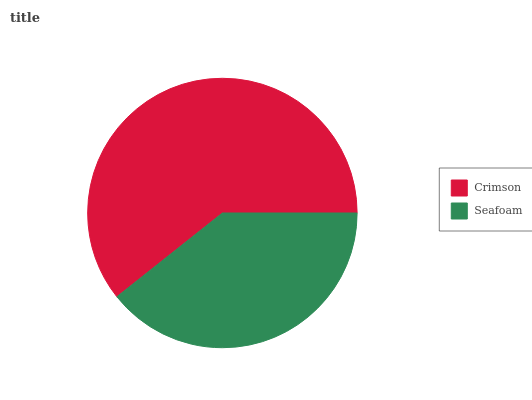Is Seafoam the minimum?
Answer yes or no. Yes. Is Crimson the maximum?
Answer yes or no. Yes. Is Seafoam the maximum?
Answer yes or no. No. Is Crimson greater than Seafoam?
Answer yes or no. Yes. Is Seafoam less than Crimson?
Answer yes or no. Yes. Is Seafoam greater than Crimson?
Answer yes or no. No. Is Crimson less than Seafoam?
Answer yes or no. No. Is Crimson the high median?
Answer yes or no. Yes. Is Seafoam the low median?
Answer yes or no. Yes. Is Seafoam the high median?
Answer yes or no. No. Is Crimson the low median?
Answer yes or no. No. 